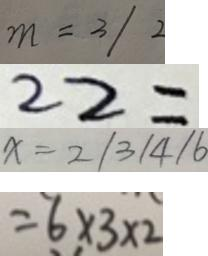<formula> <loc_0><loc_0><loc_500><loc_500>m = 3 / 2 
 2 2 = 
 x = 2 / 3 / 4 / 6 
 = 6 \times 3 \times 2</formula> 